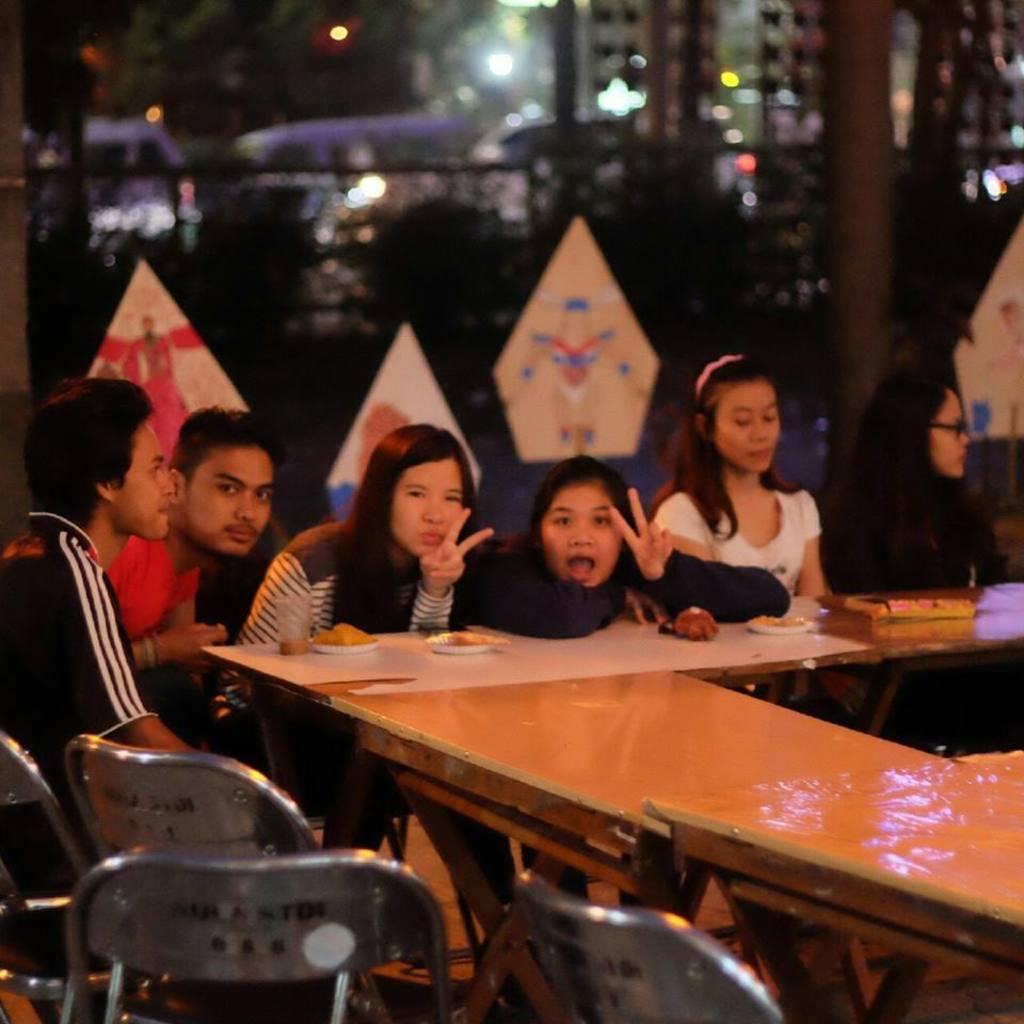What are the people in the image doing? The people in the image are sitting on a chair. What other piece of furniture is visible in the image? There is a table in the image. What type of knot is being tied by the people in the image? There is no knot being tied by the people in the image; they are simply sitting on a chair. In which country is the scene in the image taking place? The provided facts do not give any information about the country where the scene is taking place. 